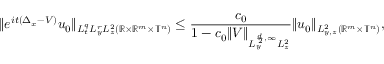Convert formula to latex. <formula><loc_0><loc_0><loc_500><loc_500>\| e ^ { i t ( \Delta _ { x } - V ) } u _ { 0 } \| _ { L _ { t } ^ { q } L _ { y } ^ { r } L _ { z } ^ { 2 } ( \mathbb { R } \times \mathbb { R } ^ { m } \times \mathbb { T } ^ { n } ) } \leq \frac { c _ { 0 } } { 1 - c _ { 0 } \| V \| _ { L _ { y } ^ { \frac { d } { 2 } , \infty } L _ { z } ^ { 2 } } } \| u _ { 0 } \| _ { L _ { y , z } ^ { 2 } ( \mathbb { R } ^ { m } \times \mathbb { T } ^ { n } ) } ,</formula> 